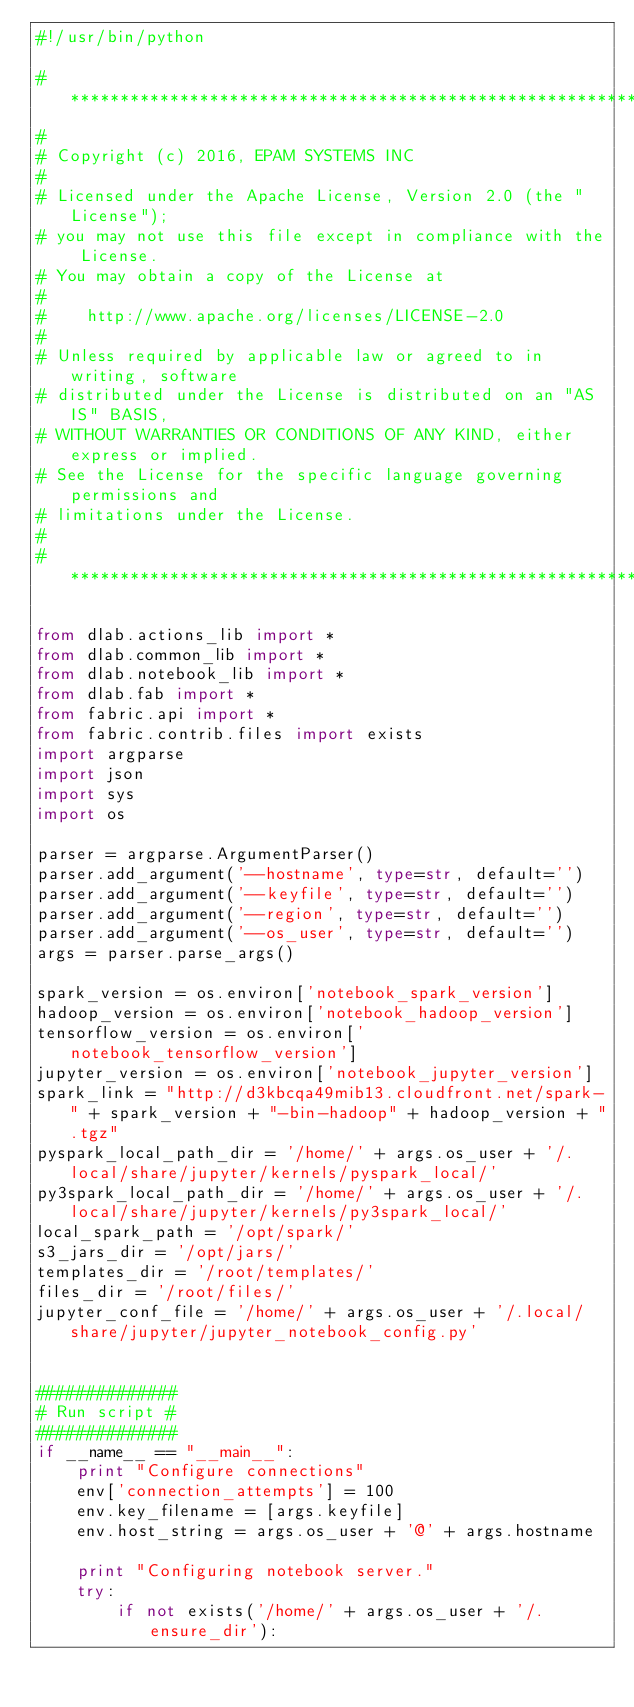<code> <loc_0><loc_0><loc_500><loc_500><_Python_>#!/usr/bin/python

# *****************************************************************************
#
# Copyright (c) 2016, EPAM SYSTEMS INC
#
# Licensed under the Apache License, Version 2.0 (the "License");
# you may not use this file except in compliance with the License.
# You may obtain a copy of the License at
#
#    http://www.apache.org/licenses/LICENSE-2.0
#
# Unless required by applicable law or agreed to in writing, software
# distributed under the License is distributed on an "AS IS" BASIS,
# WITHOUT WARRANTIES OR CONDITIONS OF ANY KIND, either express or implied.
# See the License for the specific language governing permissions and
# limitations under the License.
#
# ******************************************************************************

from dlab.actions_lib import *
from dlab.common_lib import *
from dlab.notebook_lib import *
from dlab.fab import *
from fabric.api import *
from fabric.contrib.files import exists
import argparse
import json
import sys
import os

parser = argparse.ArgumentParser()
parser.add_argument('--hostname', type=str, default='')
parser.add_argument('--keyfile', type=str, default='')
parser.add_argument('--region', type=str, default='')
parser.add_argument('--os_user', type=str, default='')
args = parser.parse_args()

spark_version = os.environ['notebook_spark_version']
hadoop_version = os.environ['notebook_hadoop_version']
tensorflow_version = os.environ['notebook_tensorflow_version']
jupyter_version = os.environ['notebook_jupyter_version']
spark_link = "http://d3kbcqa49mib13.cloudfront.net/spark-" + spark_version + "-bin-hadoop" + hadoop_version + ".tgz"
pyspark_local_path_dir = '/home/' + args.os_user + '/.local/share/jupyter/kernels/pyspark_local/'
py3spark_local_path_dir = '/home/' + args.os_user + '/.local/share/jupyter/kernels/py3spark_local/'
local_spark_path = '/opt/spark/'
s3_jars_dir = '/opt/jars/'
templates_dir = '/root/templates/'
files_dir = '/root/files/'
jupyter_conf_file = '/home/' + args.os_user + '/.local/share/jupyter/jupyter_notebook_config.py'


##############
# Run script #
##############
if __name__ == "__main__":
    print "Configure connections"
    env['connection_attempts'] = 100
    env.key_filename = [args.keyfile]
    env.host_string = args.os_user + '@' + args.hostname

    print "Configuring notebook server."
    try:
        if not exists('/home/' + args.os_user + '/.ensure_dir'):</code> 